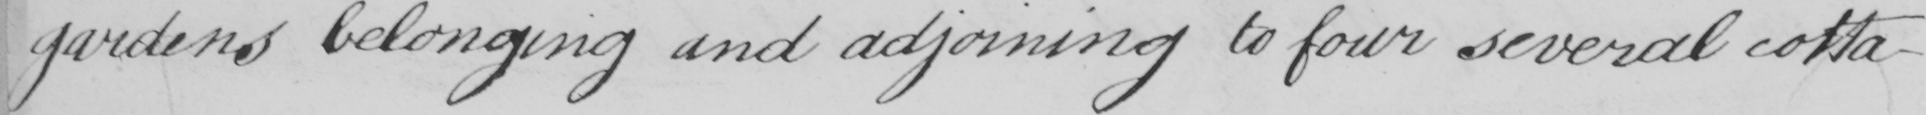Transcribe the text shown in this historical manuscript line. gardens belonging and adjoining to four several cotta- 